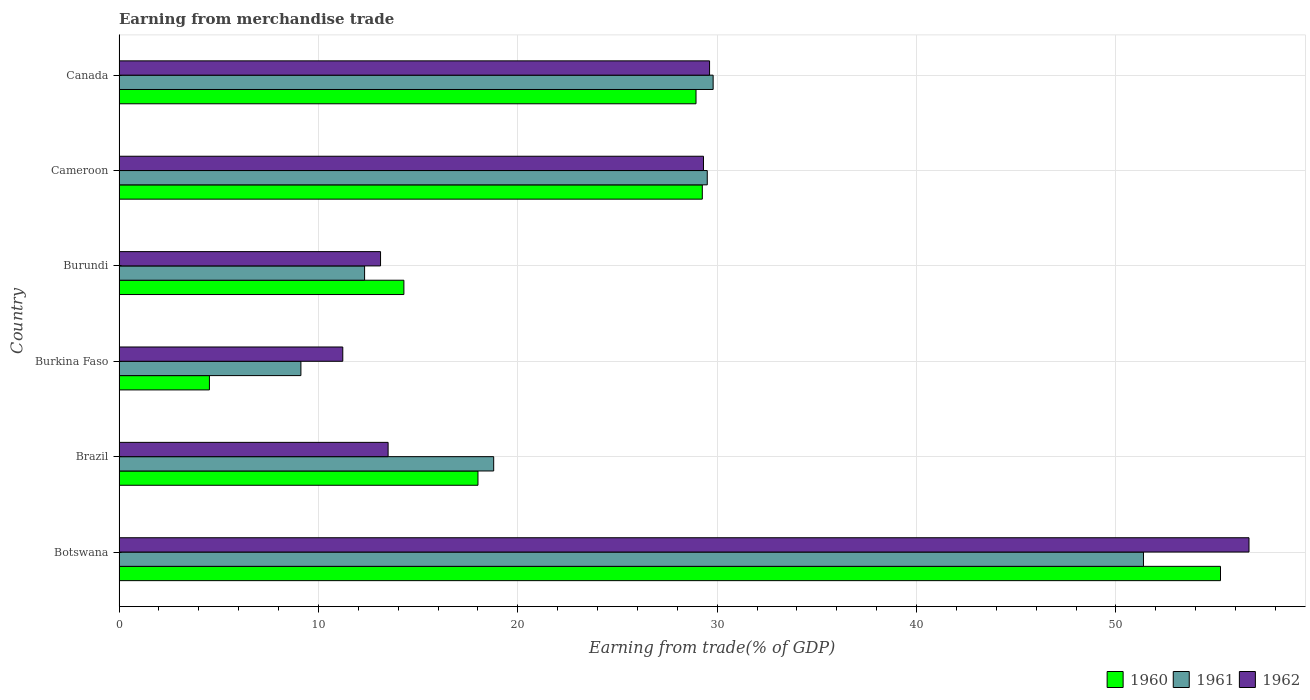How many different coloured bars are there?
Your response must be concise. 3. Are the number of bars on each tick of the Y-axis equal?
Keep it short and to the point. Yes. How many bars are there on the 1st tick from the bottom?
Ensure brevity in your answer.  3. In how many cases, is the number of bars for a given country not equal to the number of legend labels?
Give a very brief answer. 0. What is the earnings from trade in 1962 in Botswana?
Provide a short and direct response. 56.67. Across all countries, what is the maximum earnings from trade in 1960?
Keep it short and to the point. 55.24. Across all countries, what is the minimum earnings from trade in 1960?
Your response must be concise. 4.53. In which country was the earnings from trade in 1960 maximum?
Offer a very short reply. Botswana. In which country was the earnings from trade in 1960 minimum?
Your answer should be compact. Burkina Faso. What is the total earnings from trade in 1961 in the graph?
Your answer should be compact. 150.9. What is the difference between the earnings from trade in 1962 in Cameroon and that in Canada?
Ensure brevity in your answer.  -0.3. What is the difference between the earnings from trade in 1961 in Burkina Faso and the earnings from trade in 1962 in Burundi?
Provide a succinct answer. -3.99. What is the average earnings from trade in 1961 per country?
Your response must be concise. 25.15. What is the difference between the earnings from trade in 1960 and earnings from trade in 1962 in Cameroon?
Provide a short and direct response. -0.06. In how many countries, is the earnings from trade in 1960 greater than 30 %?
Offer a terse response. 1. What is the ratio of the earnings from trade in 1962 in Burkina Faso to that in Cameroon?
Your answer should be compact. 0.38. Is the difference between the earnings from trade in 1960 in Burundi and Canada greater than the difference between the earnings from trade in 1962 in Burundi and Canada?
Your answer should be very brief. Yes. What is the difference between the highest and the second highest earnings from trade in 1960?
Provide a succinct answer. 25.99. What is the difference between the highest and the lowest earnings from trade in 1960?
Provide a succinct answer. 50.71. In how many countries, is the earnings from trade in 1960 greater than the average earnings from trade in 1960 taken over all countries?
Your answer should be very brief. 3. Is the sum of the earnings from trade in 1962 in Botswana and Burundi greater than the maximum earnings from trade in 1961 across all countries?
Offer a terse response. Yes. What does the 1st bar from the top in Burkina Faso represents?
Your answer should be very brief. 1962. What does the 2nd bar from the bottom in Cameroon represents?
Your answer should be very brief. 1961. Are all the bars in the graph horizontal?
Offer a terse response. Yes. What is the difference between two consecutive major ticks on the X-axis?
Ensure brevity in your answer.  10. Does the graph contain grids?
Your response must be concise. Yes. How many legend labels are there?
Your response must be concise. 3. How are the legend labels stacked?
Provide a short and direct response. Horizontal. What is the title of the graph?
Ensure brevity in your answer.  Earning from merchandise trade. What is the label or title of the X-axis?
Offer a terse response. Earning from trade(% of GDP). What is the Earning from trade(% of GDP) of 1960 in Botswana?
Keep it short and to the point. 55.24. What is the Earning from trade(% of GDP) of 1961 in Botswana?
Make the answer very short. 51.38. What is the Earning from trade(% of GDP) in 1962 in Botswana?
Make the answer very short. 56.67. What is the Earning from trade(% of GDP) of 1960 in Brazil?
Your response must be concise. 18. What is the Earning from trade(% of GDP) of 1961 in Brazil?
Ensure brevity in your answer.  18.79. What is the Earning from trade(% of GDP) in 1962 in Brazil?
Give a very brief answer. 13.49. What is the Earning from trade(% of GDP) of 1960 in Burkina Faso?
Offer a very short reply. 4.53. What is the Earning from trade(% of GDP) in 1961 in Burkina Faso?
Your answer should be very brief. 9.12. What is the Earning from trade(% of GDP) of 1962 in Burkina Faso?
Offer a terse response. 11.22. What is the Earning from trade(% of GDP) of 1960 in Burundi?
Offer a terse response. 14.29. What is the Earning from trade(% of GDP) in 1961 in Burundi?
Ensure brevity in your answer.  12.32. What is the Earning from trade(% of GDP) in 1962 in Burundi?
Your answer should be compact. 13.11. What is the Earning from trade(% of GDP) in 1960 in Cameroon?
Keep it short and to the point. 29.25. What is the Earning from trade(% of GDP) in 1961 in Cameroon?
Give a very brief answer. 29.5. What is the Earning from trade(% of GDP) of 1962 in Cameroon?
Provide a succinct answer. 29.31. What is the Earning from trade(% of GDP) of 1960 in Canada?
Provide a short and direct response. 28.94. What is the Earning from trade(% of GDP) of 1961 in Canada?
Offer a terse response. 29.8. What is the Earning from trade(% of GDP) in 1962 in Canada?
Ensure brevity in your answer.  29.62. Across all countries, what is the maximum Earning from trade(% of GDP) of 1960?
Offer a terse response. 55.24. Across all countries, what is the maximum Earning from trade(% of GDP) of 1961?
Keep it short and to the point. 51.38. Across all countries, what is the maximum Earning from trade(% of GDP) in 1962?
Your response must be concise. 56.67. Across all countries, what is the minimum Earning from trade(% of GDP) in 1960?
Your answer should be very brief. 4.53. Across all countries, what is the minimum Earning from trade(% of GDP) of 1961?
Your response must be concise. 9.12. Across all countries, what is the minimum Earning from trade(% of GDP) in 1962?
Give a very brief answer. 11.22. What is the total Earning from trade(% of GDP) in 1960 in the graph?
Make the answer very short. 150.25. What is the total Earning from trade(% of GDP) of 1961 in the graph?
Provide a succinct answer. 150.9. What is the total Earning from trade(% of GDP) in 1962 in the graph?
Your response must be concise. 153.43. What is the difference between the Earning from trade(% of GDP) of 1960 in Botswana and that in Brazil?
Offer a terse response. 37.24. What is the difference between the Earning from trade(% of GDP) in 1961 in Botswana and that in Brazil?
Offer a very short reply. 32.59. What is the difference between the Earning from trade(% of GDP) of 1962 in Botswana and that in Brazil?
Your answer should be compact. 43.18. What is the difference between the Earning from trade(% of GDP) of 1960 in Botswana and that in Burkina Faso?
Your answer should be compact. 50.71. What is the difference between the Earning from trade(% of GDP) of 1961 in Botswana and that in Burkina Faso?
Keep it short and to the point. 42.26. What is the difference between the Earning from trade(% of GDP) of 1962 in Botswana and that in Burkina Faso?
Ensure brevity in your answer.  45.45. What is the difference between the Earning from trade(% of GDP) of 1960 in Botswana and that in Burundi?
Your answer should be compact. 40.96. What is the difference between the Earning from trade(% of GDP) in 1961 in Botswana and that in Burundi?
Keep it short and to the point. 39.06. What is the difference between the Earning from trade(% of GDP) of 1962 in Botswana and that in Burundi?
Make the answer very short. 43.56. What is the difference between the Earning from trade(% of GDP) of 1960 in Botswana and that in Cameroon?
Make the answer very short. 25.99. What is the difference between the Earning from trade(% of GDP) of 1961 in Botswana and that in Cameroon?
Your answer should be compact. 21.88. What is the difference between the Earning from trade(% of GDP) in 1962 in Botswana and that in Cameroon?
Offer a terse response. 27.36. What is the difference between the Earning from trade(% of GDP) of 1960 in Botswana and that in Canada?
Offer a terse response. 26.3. What is the difference between the Earning from trade(% of GDP) in 1961 in Botswana and that in Canada?
Provide a short and direct response. 21.58. What is the difference between the Earning from trade(% of GDP) of 1962 in Botswana and that in Canada?
Provide a short and direct response. 27.05. What is the difference between the Earning from trade(% of GDP) in 1960 in Brazil and that in Burkina Faso?
Give a very brief answer. 13.47. What is the difference between the Earning from trade(% of GDP) of 1961 in Brazil and that in Burkina Faso?
Your answer should be compact. 9.67. What is the difference between the Earning from trade(% of GDP) of 1962 in Brazil and that in Burkina Faso?
Your answer should be very brief. 2.27. What is the difference between the Earning from trade(% of GDP) of 1960 in Brazil and that in Burundi?
Offer a very short reply. 3.72. What is the difference between the Earning from trade(% of GDP) of 1961 in Brazil and that in Burundi?
Offer a terse response. 6.47. What is the difference between the Earning from trade(% of GDP) of 1962 in Brazil and that in Burundi?
Your response must be concise. 0.38. What is the difference between the Earning from trade(% of GDP) in 1960 in Brazil and that in Cameroon?
Keep it short and to the point. -11.25. What is the difference between the Earning from trade(% of GDP) of 1961 in Brazil and that in Cameroon?
Provide a succinct answer. -10.71. What is the difference between the Earning from trade(% of GDP) in 1962 in Brazil and that in Cameroon?
Offer a terse response. -15.82. What is the difference between the Earning from trade(% of GDP) in 1960 in Brazil and that in Canada?
Provide a short and direct response. -10.94. What is the difference between the Earning from trade(% of GDP) of 1961 in Brazil and that in Canada?
Provide a succinct answer. -11.01. What is the difference between the Earning from trade(% of GDP) in 1962 in Brazil and that in Canada?
Offer a very short reply. -16.12. What is the difference between the Earning from trade(% of GDP) of 1960 in Burkina Faso and that in Burundi?
Ensure brevity in your answer.  -9.75. What is the difference between the Earning from trade(% of GDP) of 1961 in Burkina Faso and that in Burundi?
Your answer should be compact. -3.19. What is the difference between the Earning from trade(% of GDP) in 1962 in Burkina Faso and that in Burundi?
Provide a succinct answer. -1.89. What is the difference between the Earning from trade(% of GDP) in 1960 in Burkina Faso and that in Cameroon?
Give a very brief answer. -24.72. What is the difference between the Earning from trade(% of GDP) in 1961 in Burkina Faso and that in Cameroon?
Keep it short and to the point. -20.38. What is the difference between the Earning from trade(% of GDP) of 1962 in Burkina Faso and that in Cameroon?
Your answer should be compact. -18.09. What is the difference between the Earning from trade(% of GDP) in 1960 in Burkina Faso and that in Canada?
Give a very brief answer. -24.41. What is the difference between the Earning from trade(% of GDP) in 1961 in Burkina Faso and that in Canada?
Your response must be concise. -20.68. What is the difference between the Earning from trade(% of GDP) in 1962 in Burkina Faso and that in Canada?
Provide a succinct answer. -18.4. What is the difference between the Earning from trade(% of GDP) in 1960 in Burundi and that in Cameroon?
Your answer should be compact. -14.97. What is the difference between the Earning from trade(% of GDP) in 1961 in Burundi and that in Cameroon?
Make the answer very short. -17.19. What is the difference between the Earning from trade(% of GDP) in 1962 in Burundi and that in Cameroon?
Make the answer very short. -16.2. What is the difference between the Earning from trade(% of GDP) in 1960 in Burundi and that in Canada?
Your answer should be compact. -14.65. What is the difference between the Earning from trade(% of GDP) of 1961 in Burundi and that in Canada?
Offer a terse response. -17.48. What is the difference between the Earning from trade(% of GDP) in 1962 in Burundi and that in Canada?
Provide a short and direct response. -16.5. What is the difference between the Earning from trade(% of GDP) in 1960 in Cameroon and that in Canada?
Provide a succinct answer. 0.32. What is the difference between the Earning from trade(% of GDP) in 1961 in Cameroon and that in Canada?
Offer a very short reply. -0.3. What is the difference between the Earning from trade(% of GDP) of 1962 in Cameroon and that in Canada?
Keep it short and to the point. -0.3. What is the difference between the Earning from trade(% of GDP) of 1960 in Botswana and the Earning from trade(% of GDP) of 1961 in Brazil?
Offer a terse response. 36.45. What is the difference between the Earning from trade(% of GDP) of 1960 in Botswana and the Earning from trade(% of GDP) of 1962 in Brazil?
Offer a terse response. 41.75. What is the difference between the Earning from trade(% of GDP) in 1961 in Botswana and the Earning from trade(% of GDP) in 1962 in Brazil?
Keep it short and to the point. 37.88. What is the difference between the Earning from trade(% of GDP) in 1960 in Botswana and the Earning from trade(% of GDP) in 1961 in Burkina Faso?
Your answer should be compact. 46.12. What is the difference between the Earning from trade(% of GDP) in 1960 in Botswana and the Earning from trade(% of GDP) in 1962 in Burkina Faso?
Your answer should be very brief. 44.02. What is the difference between the Earning from trade(% of GDP) in 1961 in Botswana and the Earning from trade(% of GDP) in 1962 in Burkina Faso?
Keep it short and to the point. 40.16. What is the difference between the Earning from trade(% of GDP) in 1960 in Botswana and the Earning from trade(% of GDP) in 1961 in Burundi?
Your answer should be compact. 42.93. What is the difference between the Earning from trade(% of GDP) of 1960 in Botswana and the Earning from trade(% of GDP) of 1962 in Burundi?
Offer a very short reply. 42.13. What is the difference between the Earning from trade(% of GDP) in 1961 in Botswana and the Earning from trade(% of GDP) in 1962 in Burundi?
Provide a short and direct response. 38.26. What is the difference between the Earning from trade(% of GDP) of 1960 in Botswana and the Earning from trade(% of GDP) of 1961 in Cameroon?
Offer a terse response. 25.74. What is the difference between the Earning from trade(% of GDP) of 1960 in Botswana and the Earning from trade(% of GDP) of 1962 in Cameroon?
Ensure brevity in your answer.  25.93. What is the difference between the Earning from trade(% of GDP) in 1961 in Botswana and the Earning from trade(% of GDP) in 1962 in Cameroon?
Your answer should be compact. 22.07. What is the difference between the Earning from trade(% of GDP) in 1960 in Botswana and the Earning from trade(% of GDP) in 1961 in Canada?
Provide a succinct answer. 25.45. What is the difference between the Earning from trade(% of GDP) of 1960 in Botswana and the Earning from trade(% of GDP) of 1962 in Canada?
Make the answer very short. 25.63. What is the difference between the Earning from trade(% of GDP) in 1961 in Botswana and the Earning from trade(% of GDP) in 1962 in Canada?
Keep it short and to the point. 21.76. What is the difference between the Earning from trade(% of GDP) of 1960 in Brazil and the Earning from trade(% of GDP) of 1961 in Burkina Faso?
Offer a very short reply. 8.88. What is the difference between the Earning from trade(% of GDP) in 1960 in Brazil and the Earning from trade(% of GDP) in 1962 in Burkina Faso?
Provide a short and direct response. 6.78. What is the difference between the Earning from trade(% of GDP) of 1961 in Brazil and the Earning from trade(% of GDP) of 1962 in Burkina Faso?
Your answer should be compact. 7.57. What is the difference between the Earning from trade(% of GDP) in 1960 in Brazil and the Earning from trade(% of GDP) in 1961 in Burundi?
Keep it short and to the point. 5.69. What is the difference between the Earning from trade(% of GDP) of 1960 in Brazil and the Earning from trade(% of GDP) of 1962 in Burundi?
Make the answer very short. 4.89. What is the difference between the Earning from trade(% of GDP) of 1961 in Brazil and the Earning from trade(% of GDP) of 1962 in Burundi?
Keep it short and to the point. 5.68. What is the difference between the Earning from trade(% of GDP) in 1960 in Brazil and the Earning from trade(% of GDP) in 1962 in Cameroon?
Your response must be concise. -11.31. What is the difference between the Earning from trade(% of GDP) in 1961 in Brazil and the Earning from trade(% of GDP) in 1962 in Cameroon?
Keep it short and to the point. -10.52. What is the difference between the Earning from trade(% of GDP) of 1960 in Brazil and the Earning from trade(% of GDP) of 1961 in Canada?
Ensure brevity in your answer.  -11.8. What is the difference between the Earning from trade(% of GDP) in 1960 in Brazil and the Earning from trade(% of GDP) in 1962 in Canada?
Offer a very short reply. -11.62. What is the difference between the Earning from trade(% of GDP) in 1961 in Brazil and the Earning from trade(% of GDP) in 1962 in Canada?
Offer a very short reply. -10.83. What is the difference between the Earning from trade(% of GDP) of 1960 in Burkina Faso and the Earning from trade(% of GDP) of 1961 in Burundi?
Offer a very short reply. -7.78. What is the difference between the Earning from trade(% of GDP) in 1960 in Burkina Faso and the Earning from trade(% of GDP) in 1962 in Burundi?
Make the answer very short. -8.58. What is the difference between the Earning from trade(% of GDP) of 1961 in Burkina Faso and the Earning from trade(% of GDP) of 1962 in Burundi?
Provide a short and direct response. -3.99. What is the difference between the Earning from trade(% of GDP) in 1960 in Burkina Faso and the Earning from trade(% of GDP) in 1961 in Cameroon?
Make the answer very short. -24.97. What is the difference between the Earning from trade(% of GDP) in 1960 in Burkina Faso and the Earning from trade(% of GDP) in 1962 in Cameroon?
Your response must be concise. -24.78. What is the difference between the Earning from trade(% of GDP) in 1961 in Burkina Faso and the Earning from trade(% of GDP) in 1962 in Cameroon?
Keep it short and to the point. -20.19. What is the difference between the Earning from trade(% of GDP) in 1960 in Burkina Faso and the Earning from trade(% of GDP) in 1961 in Canada?
Make the answer very short. -25.26. What is the difference between the Earning from trade(% of GDP) of 1960 in Burkina Faso and the Earning from trade(% of GDP) of 1962 in Canada?
Make the answer very short. -25.08. What is the difference between the Earning from trade(% of GDP) in 1961 in Burkina Faso and the Earning from trade(% of GDP) in 1962 in Canada?
Your response must be concise. -20.5. What is the difference between the Earning from trade(% of GDP) in 1960 in Burundi and the Earning from trade(% of GDP) in 1961 in Cameroon?
Make the answer very short. -15.22. What is the difference between the Earning from trade(% of GDP) in 1960 in Burundi and the Earning from trade(% of GDP) in 1962 in Cameroon?
Your answer should be compact. -15.03. What is the difference between the Earning from trade(% of GDP) in 1961 in Burundi and the Earning from trade(% of GDP) in 1962 in Cameroon?
Your answer should be compact. -17. What is the difference between the Earning from trade(% of GDP) in 1960 in Burundi and the Earning from trade(% of GDP) in 1961 in Canada?
Make the answer very short. -15.51. What is the difference between the Earning from trade(% of GDP) of 1960 in Burundi and the Earning from trade(% of GDP) of 1962 in Canada?
Provide a short and direct response. -15.33. What is the difference between the Earning from trade(% of GDP) of 1961 in Burundi and the Earning from trade(% of GDP) of 1962 in Canada?
Make the answer very short. -17.3. What is the difference between the Earning from trade(% of GDP) of 1960 in Cameroon and the Earning from trade(% of GDP) of 1961 in Canada?
Your response must be concise. -0.54. What is the difference between the Earning from trade(% of GDP) of 1960 in Cameroon and the Earning from trade(% of GDP) of 1962 in Canada?
Provide a succinct answer. -0.36. What is the difference between the Earning from trade(% of GDP) in 1961 in Cameroon and the Earning from trade(% of GDP) in 1962 in Canada?
Your response must be concise. -0.12. What is the average Earning from trade(% of GDP) of 1960 per country?
Keep it short and to the point. 25.04. What is the average Earning from trade(% of GDP) in 1961 per country?
Keep it short and to the point. 25.15. What is the average Earning from trade(% of GDP) of 1962 per country?
Your answer should be compact. 25.57. What is the difference between the Earning from trade(% of GDP) of 1960 and Earning from trade(% of GDP) of 1961 in Botswana?
Give a very brief answer. 3.86. What is the difference between the Earning from trade(% of GDP) of 1960 and Earning from trade(% of GDP) of 1962 in Botswana?
Ensure brevity in your answer.  -1.43. What is the difference between the Earning from trade(% of GDP) of 1961 and Earning from trade(% of GDP) of 1962 in Botswana?
Your response must be concise. -5.29. What is the difference between the Earning from trade(% of GDP) of 1960 and Earning from trade(% of GDP) of 1961 in Brazil?
Offer a very short reply. -0.79. What is the difference between the Earning from trade(% of GDP) in 1960 and Earning from trade(% of GDP) in 1962 in Brazil?
Keep it short and to the point. 4.51. What is the difference between the Earning from trade(% of GDP) in 1961 and Earning from trade(% of GDP) in 1962 in Brazil?
Your response must be concise. 5.3. What is the difference between the Earning from trade(% of GDP) of 1960 and Earning from trade(% of GDP) of 1961 in Burkina Faso?
Your answer should be compact. -4.59. What is the difference between the Earning from trade(% of GDP) of 1960 and Earning from trade(% of GDP) of 1962 in Burkina Faso?
Your response must be concise. -6.69. What is the difference between the Earning from trade(% of GDP) of 1961 and Earning from trade(% of GDP) of 1962 in Burkina Faso?
Keep it short and to the point. -2.1. What is the difference between the Earning from trade(% of GDP) of 1960 and Earning from trade(% of GDP) of 1961 in Burundi?
Provide a succinct answer. 1.97. What is the difference between the Earning from trade(% of GDP) in 1960 and Earning from trade(% of GDP) in 1962 in Burundi?
Make the answer very short. 1.17. What is the difference between the Earning from trade(% of GDP) of 1961 and Earning from trade(% of GDP) of 1962 in Burundi?
Make the answer very short. -0.8. What is the difference between the Earning from trade(% of GDP) in 1960 and Earning from trade(% of GDP) in 1961 in Cameroon?
Ensure brevity in your answer.  -0.25. What is the difference between the Earning from trade(% of GDP) of 1960 and Earning from trade(% of GDP) of 1962 in Cameroon?
Your response must be concise. -0.06. What is the difference between the Earning from trade(% of GDP) in 1961 and Earning from trade(% of GDP) in 1962 in Cameroon?
Ensure brevity in your answer.  0.19. What is the difference between the Earning from trade(% of GDP) in 1960 and Earning from trade(% of GDP) in 1961 in Canada?
Make the answer very short. -0.86. What is the difference between the Earning from trade(% of GDP) in 1960 and Earning from trade(% of GDP) in 1962 in Canada?
Provide a short and direct response. -0.68. What is the difference between the Earning from trade(% of GDP) in 1961 and Earning from trade(% of GDP) in 1962 in Canada?
Ensure brevity in your answer.  0.18. What is the ratio of the Earning from trade(% of GDP) of 1960 in Botswana to that in Brazil?
Give a very brief answer. 3.07. What is the ratio of the Earning from trade(% of GDP) in 1961 in Botswana to that in Brazil?
Your response must be concise. 2.73. What is the ratio of the Earning from trade(% of GDP) of 1962 in Botswana to that in Brazil?
Offer a very short reply. 4.2. What is the ratio of the Earning from trade(% of GDP) of 1960 in Botswana to that in Burkina Faso?
Make the answer very short. 12.19. What is the ratio of the Earning from trade(% of GDP) in 1961 in Botswana to that in Burkina Faso?
Ensure brevity in your answer.  5.63. What is the ratio of the Earning from trade(% of GDP) in 1962 in Botswana to that in Burkina Faso?
Your response must be concise. 5.05. What is the ratio of the Earning from trade(% of GDP) of 1960 in Botswana to that in Burundi?
Offer a very short reply. 3.87. What is the ratio of the Earning from trade(% of GDP) in 1961 in Botswana to that in Burundi?
Your answer should be very brief. 4.17. What is the ratio of the Earning from trade(% of GDP) in 1962 in Botswana to that in Burundi?
Provide a succinct answer. 4.32. What is the ratio of the Earning from trade(% of GDP) of 1960 in Botswana to that in Cameroon?
Give a very brief answer. 1.89. What is the ratio of the Earning from trade(% of GDP) of 1961 in Botswana to that in Cameroon?
Your answer should be compact. 1.74. What is the ratio of the Earning from trade(% of GDP) of 1962 in Botswana to that in Cameroon?
Your response must be concise. 1.93. What is the ratio of the Earning from trade(% of GDP) of 1960 in Botswana to that in Canada?
Provide a short and direct response. 1.91. What is the ratio of the Earning from trade(% of GDP) of 1961 in Botswana to that in Canada?
Keep it short and to the point. 1.72. What is the ratio of the Earning from trade(% of GDP) in 1962 in Botswana to that in Canada?
Ensure brevity in your answer.  1.91. What is the ratio of the Earning from trade(% of GDP) in 1960 in Brazil to that in Burkina Faso?
Your answer should be very brief. 3.97. What is the ratio of the Earning from trade(% of GDP) in 1961 in Brazil to that in Burkina Faso?
Provide a short and direct response. 2.06. What is the ratio of the Earning from trade(% of GDP) in 1962 in Brazil to that in Burkina Faso?
Your answer should be compact. 1.2. What is the ratio of the Earning from trade(% of GDP) in 1960 in Brazil to that in Burundi?
Ensure brevity in your answer.  1.26. What is the ratio of the Earning from trade(% of GDP) in 1961 in Brazil to that in Burundi?
Provide a short and direct response. 1.53. What is the ratio of the Earning from trade(% of GDP) in 1960 in Brazil to that in Cameroon?
Offer a terse response. 0.62. What is the ratio of the Earning from trade(% of GDP) in 1961 in Brazil to that in Cameroon?
Your answer should be very brief. 0.64. What is the ratio of the Earning from trade(% of GDP) of 1962 in Brazil to that in Cameroon?
Your response must be concise. 0.46. What is the ratio of the Earning from trade(% of GDP) in 1960 in Brazil to that in Canada?
Offer a terse response. 0.62. What is the ratio of the Earning from trade(% of GDP) of 1961 in Brazil to that in Canada?
Offer a very short reply. 0.63. What is the ratio of the Earning from trade(% of GDP) in 1962 in Brazil to that in Canada?
Give a very brief answer. 0.46. What is the ratio of the Earning from trade(% of GDP) in 1960 in Burkina Faso to that in Burundi?
Your response must be concise. 0.32. What is the ratio of the Earning from trade(% of GDP) of 1961 in Burkina Faso to that in Burundi?
Keep it short and to the point. 0.74. What is the ratio of the Earning from trade(% of GDP) of 1962 in Burkina Faso to that in Burundi?
Make the answer very short. 0.86. What is the ratio of the Earning from trade(% of GDP) in 1960 in Burkina Faso to that in Cameroon?
Offer a very short reply. 0.15. What is the ratio of the Earning from trade(% of GDP) of 1961 in Burkina Faso to that in Cameroon?
Provide a succinct answer. 0.31. What is the ratio of the Earning from trade(% of GDP) in 1962 in Burkina Faso to that in Cameroon?
Your answer should be compact. 0.38. What is the ratio of the Earning from trade(% of GDP) in 1960 in Burkina Faso to that in Canada?
Offer a terse response. 0.16. What is the ratio of the Earning from trade(% of GDP) of 1961 in Burkina Faso to that in Canada?
Make the answer very short. 0.31. What is the ratio of the Earning from trade(% of GDP) of 1962 in Burkina Faso to that in Canada?
Provide a succinct answer. 0.38. What is the ratio of the Earning from trade(% of GDP) of 1960 in Burundi to that in Cameroon?
Give a very brief answer. 0.49. What is the ratio of the Earning from trade(% of GDP) of 1961 in Burundi to that in Cameroon?
Offer a terse response. 0.42. What is the ratio of the Earning from trade(% of GDP) in 1962 in Burundi to that in Cameroon?
Keep it short and to the point. 0.45. What is the ratio of the Earning from trade(% of GDP) of 1960 in Burundi to that in Canada?
Provide a succinct answer. 0.49. What is the ratio of the Earning from trade(% of GDP) in 1961 in Burundi to that in Canada?
Provide a short and direct response. 0.41. What is the ratio of the Earning from trade(% of GDP) in 1962 in Burundi to that in Canada?
Provide a short and direct response. 0.44. What is the ratio of the Earning from trade(% of GDP) in 1960 in Cameroon to that in Canada?
Make the answer very short. 1.01. What is the ratio of the Earning from trade(% of GDP) of 1961 in Cameroon to that in Canada?
Provide a short and direct response. 0.99. What is the difference between the highest and the second highest Earning from trade(% of GDP) in 1960?
Your answer should be compact. 25.99. What is the difference between the highest and the second highest Earning from trade(% of GDP) in 1961?
Make the answer very short. 21.58. What is the difference between the highest and the second highest Earning from trade(% of GDP) of 1962?
Make the answer very short. 27.05. What is the difference between the highest and the lowest Earning from trade(% of GDP) in 1960?
Your answer should be very brief. 50.71. What is the difference between the highest and the lowest Earning from trade(% of GDP) in 1961?
Your answer should be very brief. 42.26. What is the difference between the highest and the lowest Earning from trade(% of GDP) of 1962?
Offer a very short reply. 45.45. 